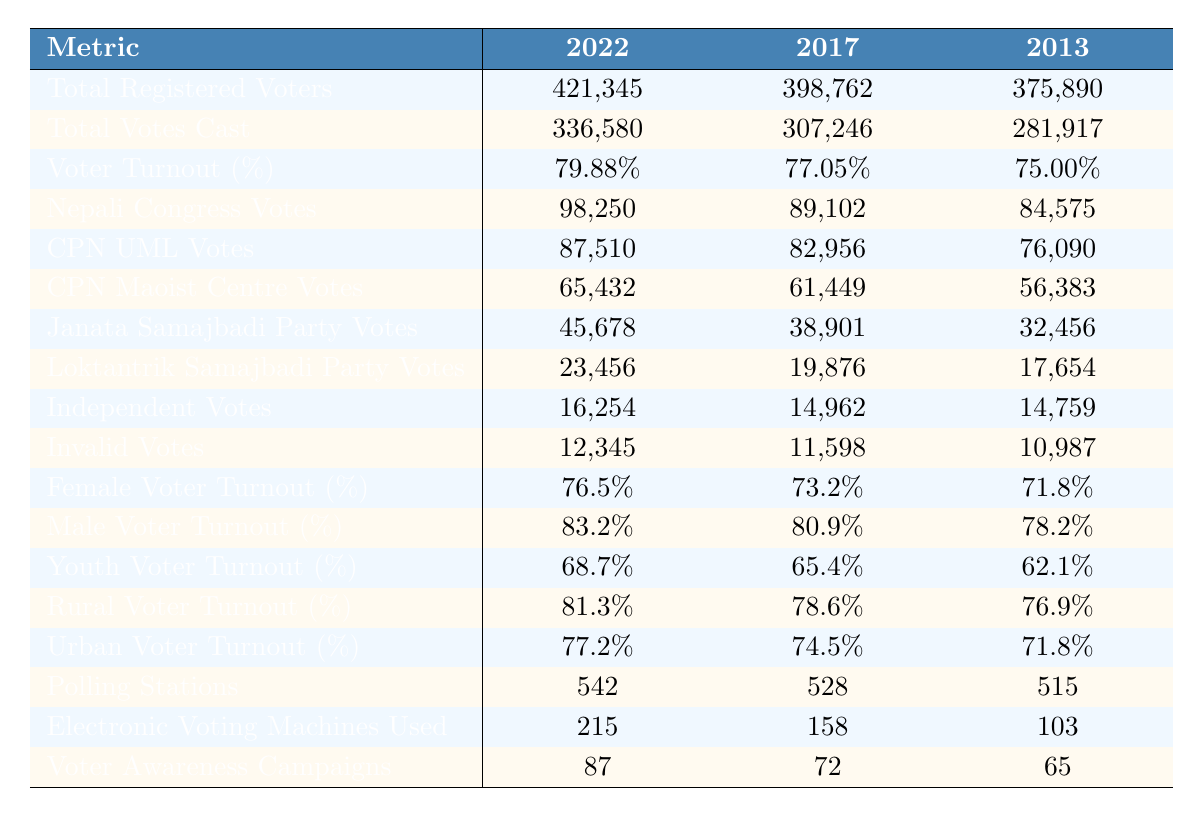What was the voter turnout percentage in the 2022 elections? The table shows that the voter turnout percentage for the 2022 elections is listed directly under that year, which is 79.88%.
Answer: 79.88% How many total registered voters were there in 2017? By examining the 2017 row, the total registered voters figure is found to be 398,762.
Answer: 398,762 What was the total number of votes cast in 2013? The table indicates that in 2013, a total of 281,917 votes were cast which is directly provided in that row.
Answer: 281,917 Which party received the highest number of votes in the 2022 election? The votes for each party are listed, and Nepali Congress has the highest votes at 98,250 in 2022.
Answer: Nepali Congress What percentage of voters in 2022 were female? The female voter turnout percentage for 2022 is provided in the table and is 76.5%.
Answer: 76.5% How many more votes were cast in 2022 compared to 2013? To find the difference, subtract the total votes cast in 2013 (281,917) from those cast in 2022 (336,580): 336,580 - 281,917 = 54,663.
Answer: 54,663 What was the percentage increase in voter turnout from 2013 to 2022? The voter turnout percentages are 75.00% in 2013 and 79.88% in 2022. The increase is calculated as follows: 79.88% - 75.00% = 4.88%.
Answer: 4.88% Did the total registered voters decrease from 2013 to 2017? Comparing the total registered voters in 2013 (375,890) with 2017 (398,762), we find that the number increased, hence the statement is false.
Answer: No What was the average voter turnout percentage for females over the three elections? To find the average, sum the female voter turnout percentages (76.5 + 73.2 + 71.8) = 221.5, then divide by 3: 221.5 / 3 = 73.83%.
Answer: 73.83% Which year had the highest number of invalid votes? By looking at the invalid votes row, we see that the highest number of invalid votes is 12,345 in 2022.
Answer: 2022 What was the voter turnout percentage for males in 2017? The table provides this information directly, showing that the male voter turnout percentage for 2017 is 80.9%.
Answer: 80.9% How many voter awareness campaigns were conducted in 2017? The number of voter awareness campaigns conducted in 2017 is found in the respective row, which indicates 72 campaigns were held.
Answer: 72 What is the total number of polling stations used across all three elections? The numbers of polling stations for each year are 542, 528, and 515. Adding these amounts together gives: 542 + 528 + 515 = 1585.
Answer: 1585 